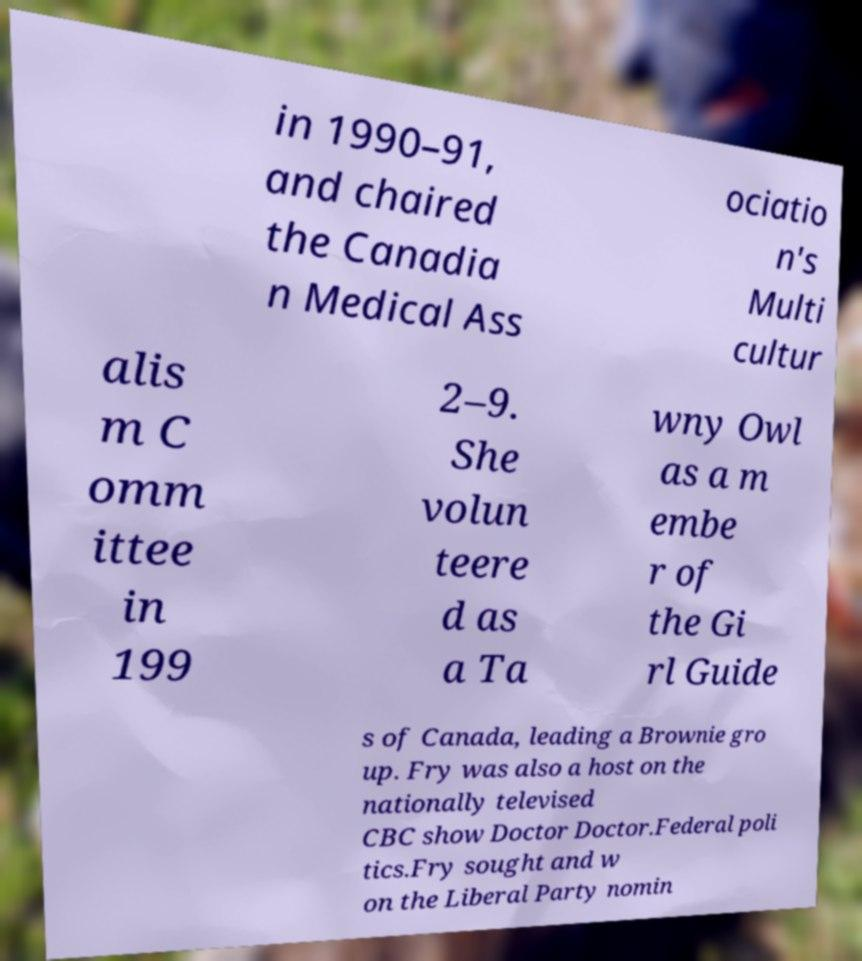Please identify and transcribe the text found in this image. in 1990–91, and chaired the Canadia n Medical Ass ociatio n's Multi cultur alis m C omm ittee in 199 2–9. She volun teere d as a Ta wny Owl as a m embe r of the Gi rl Guide s of Canada, leading a Brownie gro up. Fry was also a host on the nationally televised CBC show Doctor Doctor.Federal poli tics.Fry sought and w on the Liberal Party nomin 